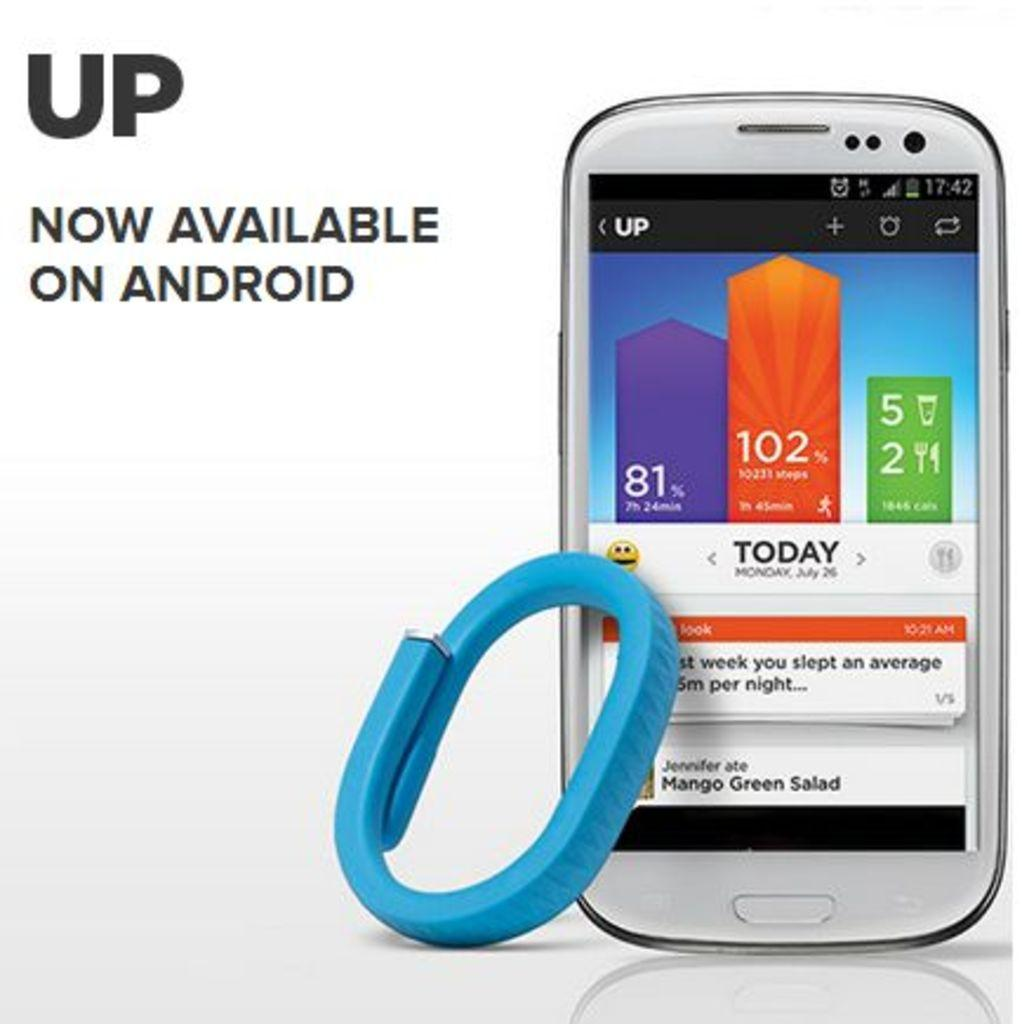Provide a one-sentence caption for the provided image. A phone screen shows the day as Monday. 